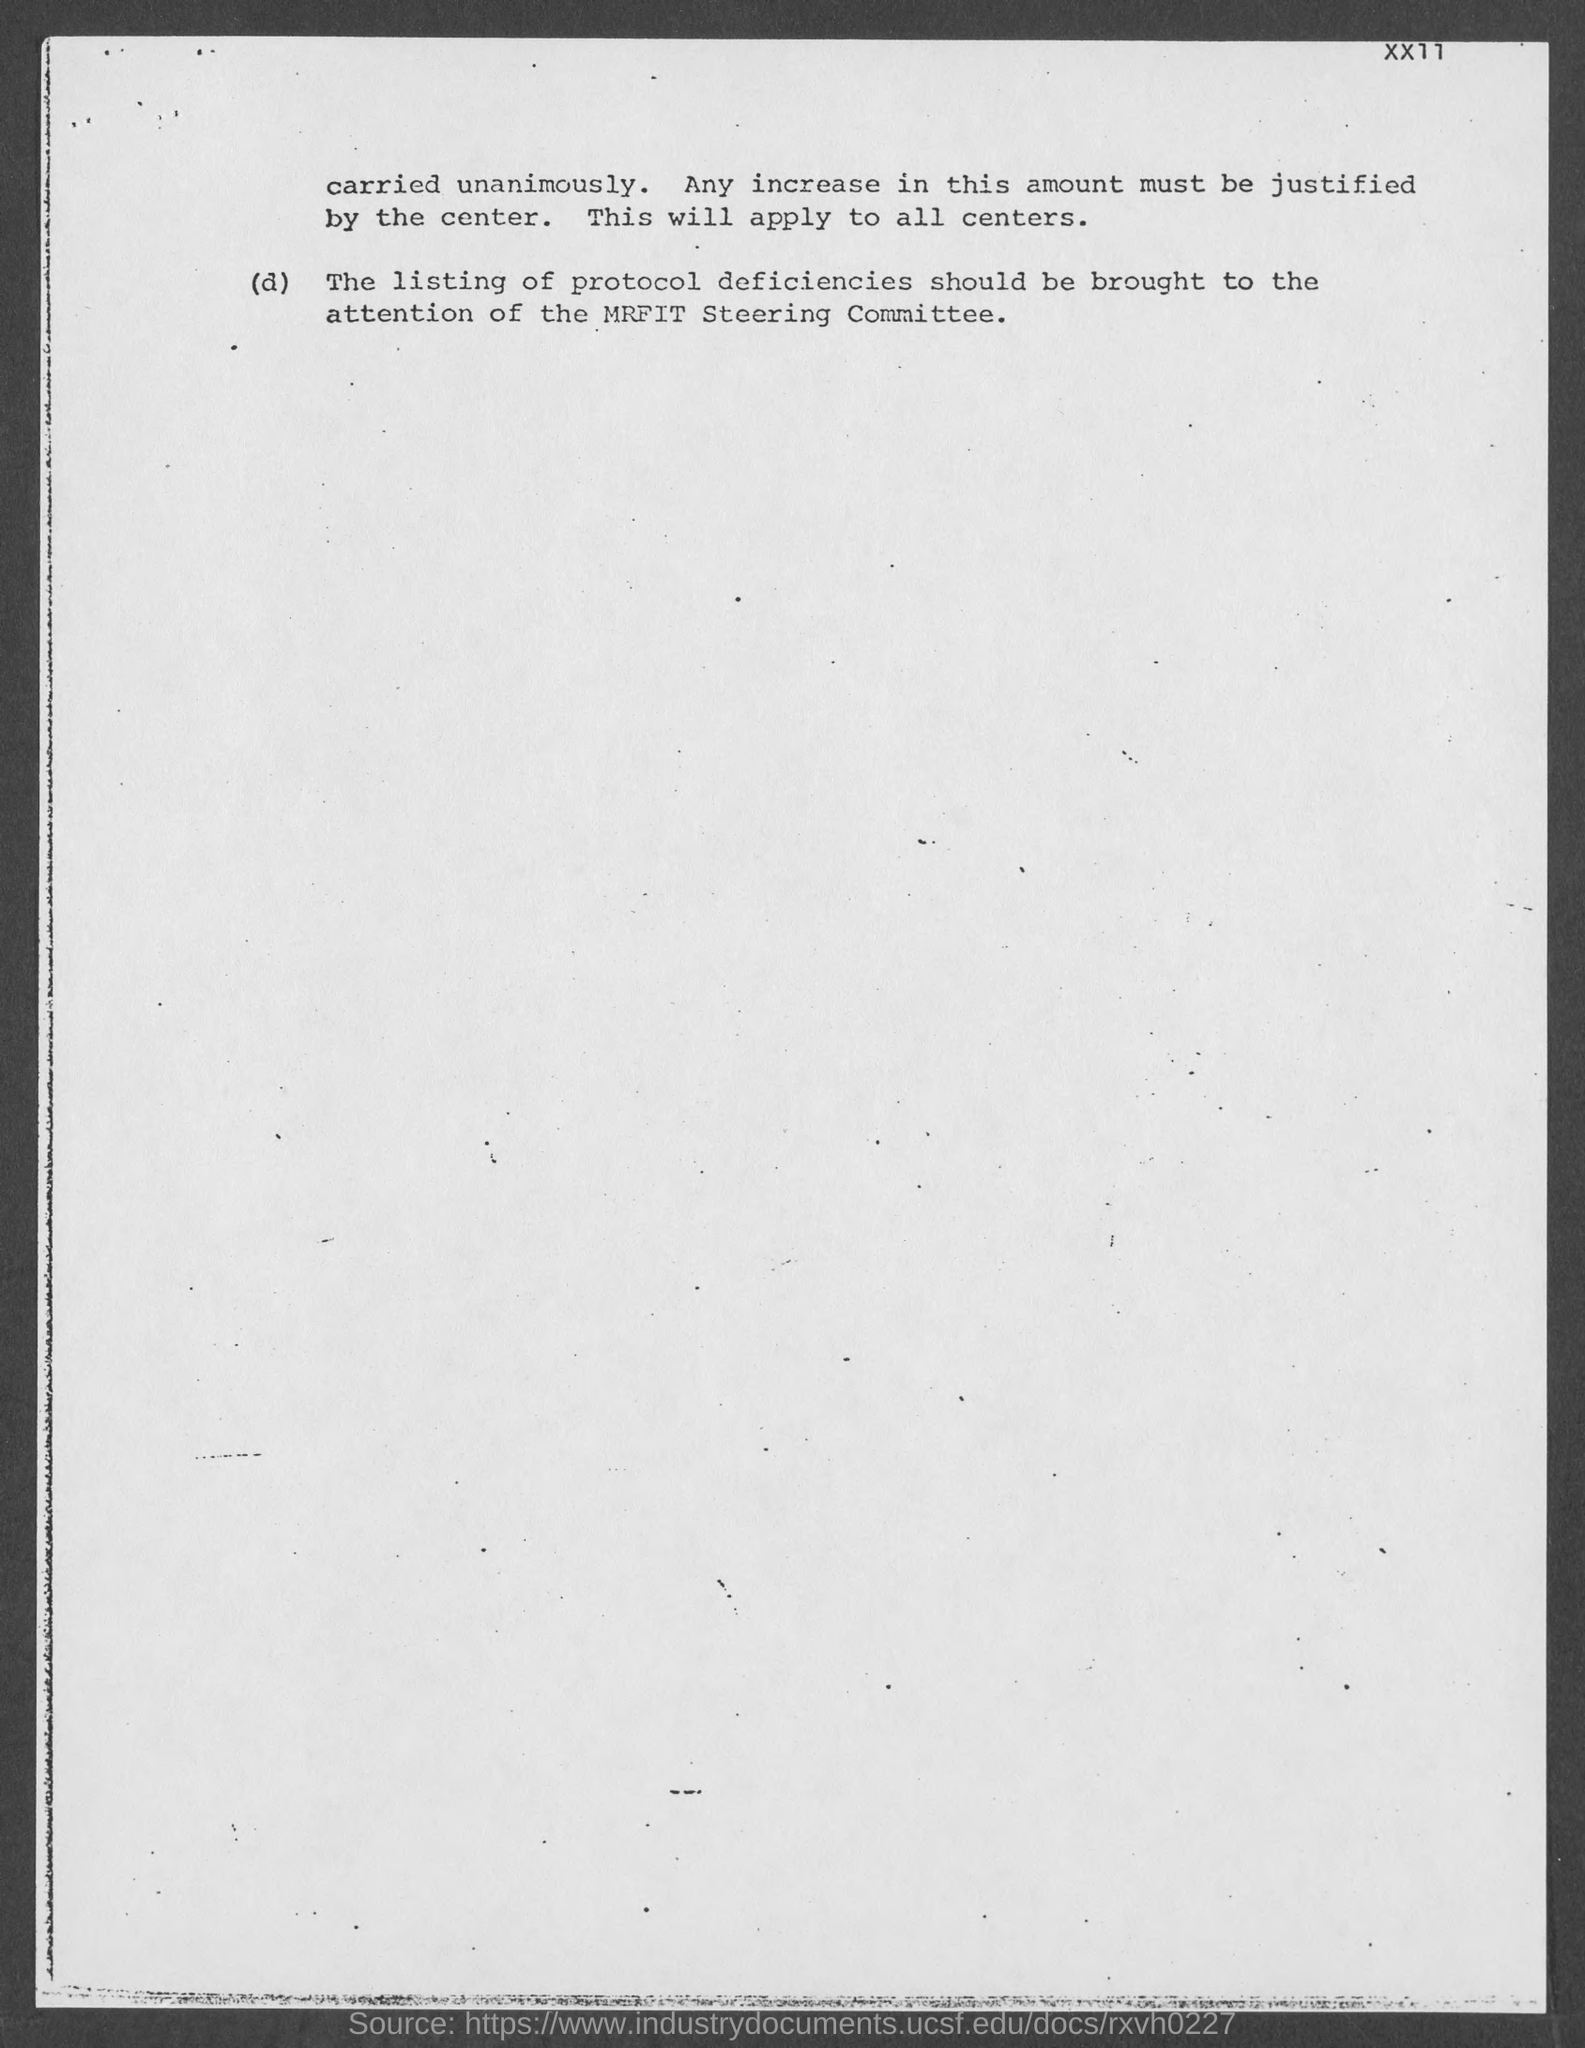Which committee takes care of protocol deficiencies ?
Provide a succinct answer. MRFIT Steering Committee. 